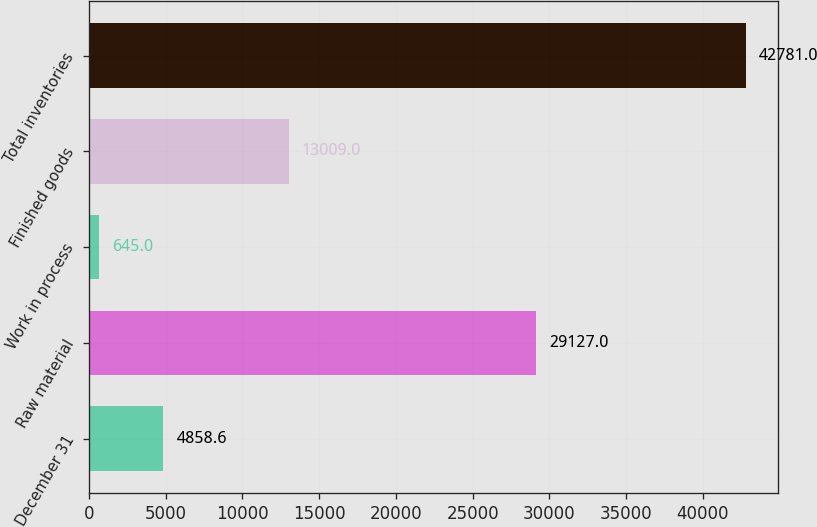Convert chart. <chart><loc_0><loc_0><loc_500><loc_500><bar_chart><fcel>December 31<fcel>Raw material<fcel>Work in process<fcel>Finished goods<fcel>Total inventories<nl><fcel>4858.6<fcel>29127<fcel>645<fcel>13009<fcel>42781<nl></chart> 